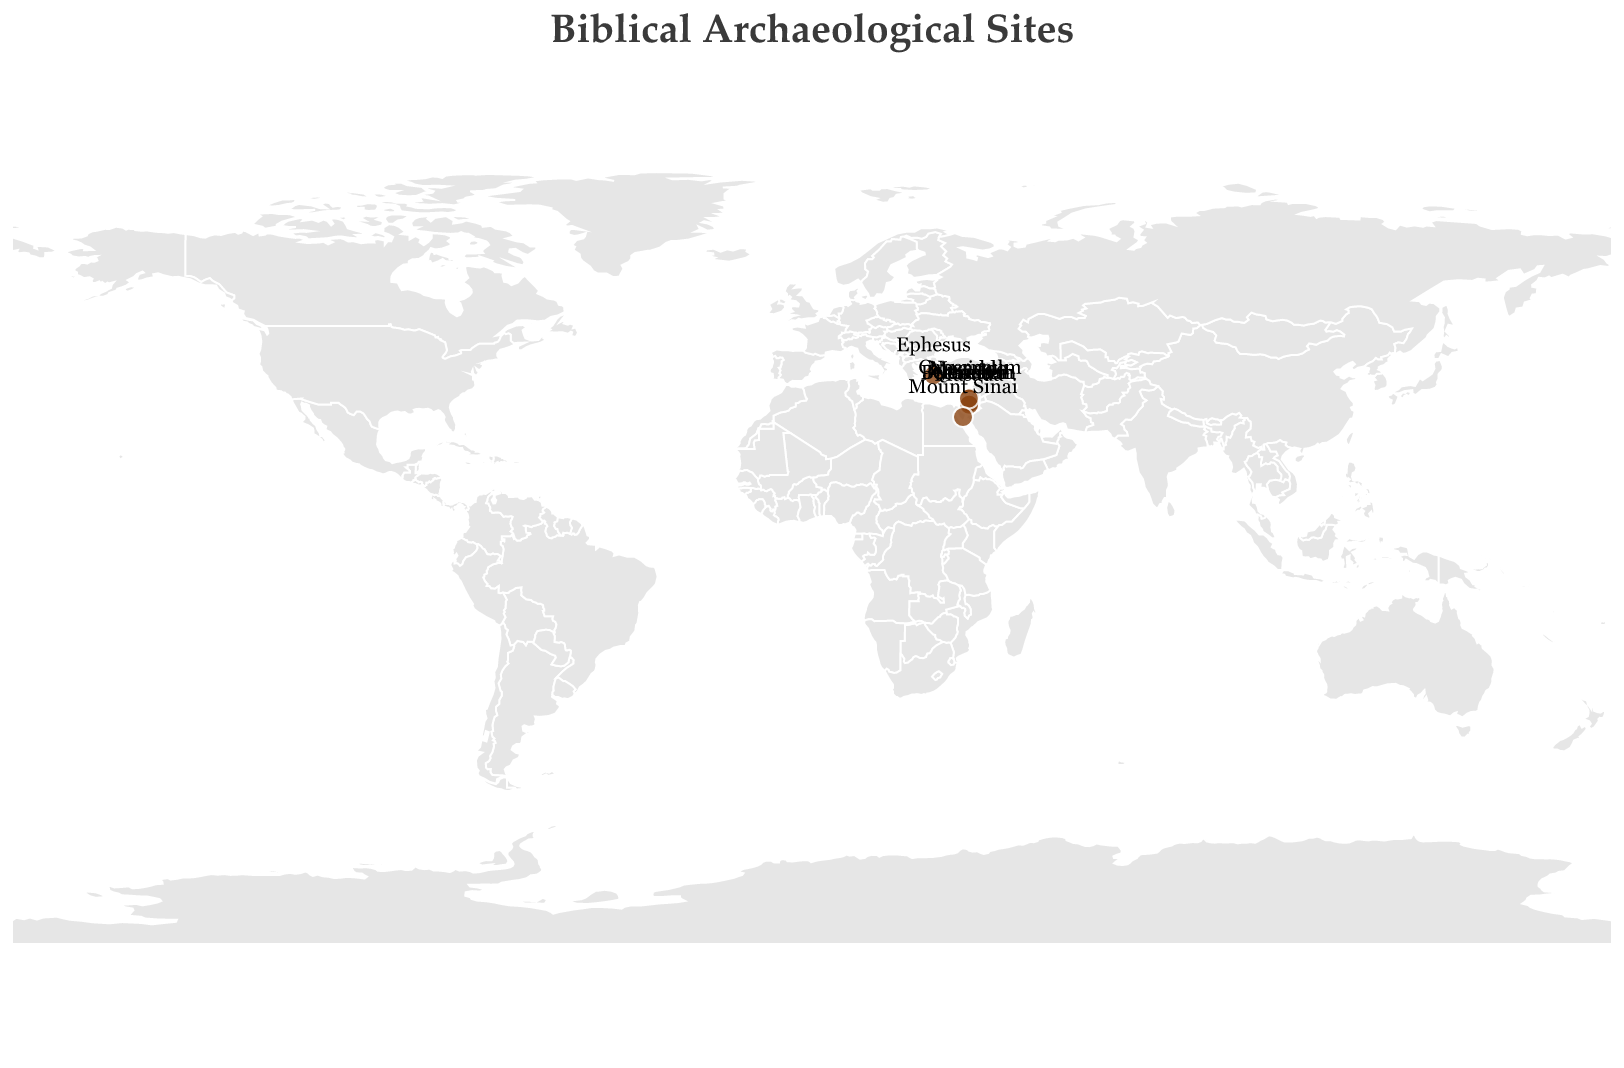What's the title of the plot? The title is prominently displayed at the top of the plot, written in a larger font size. It reads "Biblical Archaeological Sites".
Answer: Biblical Archaeological Sites How many archaeological sites are marked on the map? By counting the circles on the map, we can determine the number of archaeological sites. There are 10 circles representing the sites.
Answer: 10 Which site is located furthest north? To find the site furthest north, we need to identify the site with the highest latitude value. Ephesus, with a latitude of 37.9398, is the northernmost site.
Answer: Ephesus Which site is located furthest south? To find the site furthest south, we need to identify the site with the lowest latitude value. Mount Sinai, with a latitude of 28.5392, is the southernmost site.
Answer: Mount Sinai Which two sites are the closest to each other? To determine the closest sites, we compare the latitude and longitude values of all markers. Jerusalem and Bethlehem are very close as both are in the same region with only minor differences in their coordinates.
Answer: Jerusalem and Bethlehem Which site is closest to the Sea of Galilee? The plot indicates that Capernaum is near the Sea of Galilee, as mentioned in its description. It also has coordinates placing it in that region.
Answer: Capernaum Is Megiddo located north or south of Nazareth? By comparing the latitude values, we see that Megiddo (32.5850) is south of Nazareth (32.7021).
Answer: South Among the sites, which is located in present-day Turkey? The description of Ephesus includes that it was the city where Paul preached and is located in present-day Turkey.
Answer: Ephesus Identify two ancient cities within what is now Israel. By looking at the map and the descriptions, we see that Jerusalem and Bethlehem are both within modern-day Israel.
Answer: Jerusalem and Bethlehem Which site has the highest historical significance related to the New Testament? Given the context in the figure, Bethlehem is identified as the birthplace of Jesus Christ, a significant event in the New Testament.
Answer: Bethlehem 